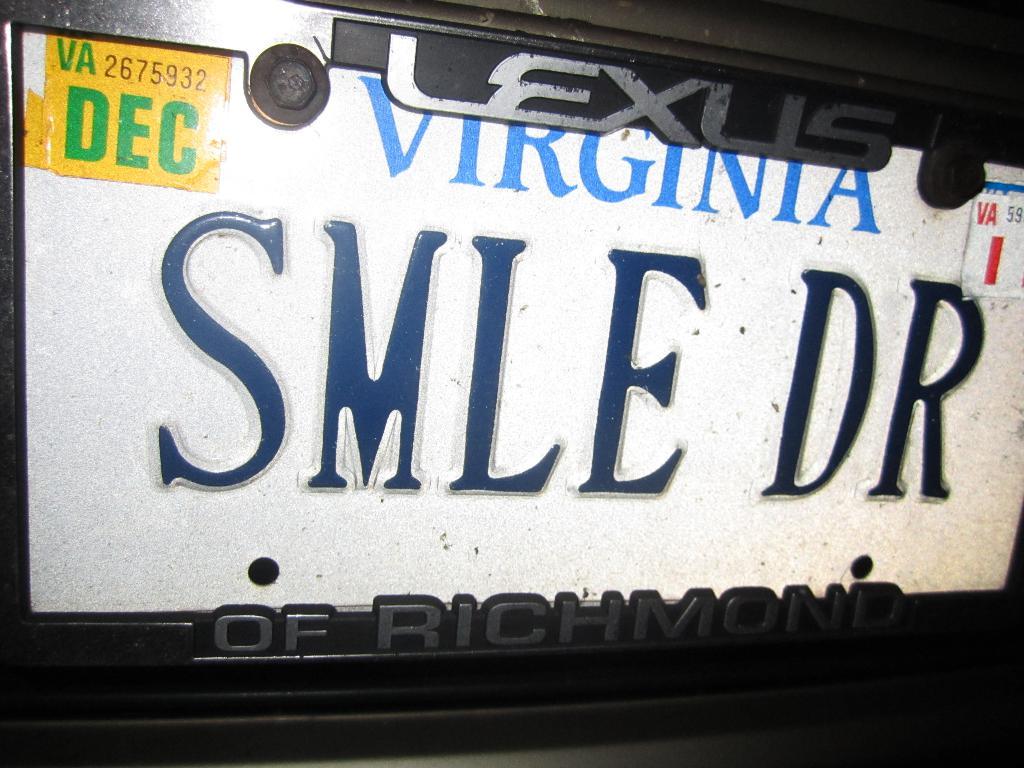What state is this license plate from?
Make the answer very short. Virginia. 